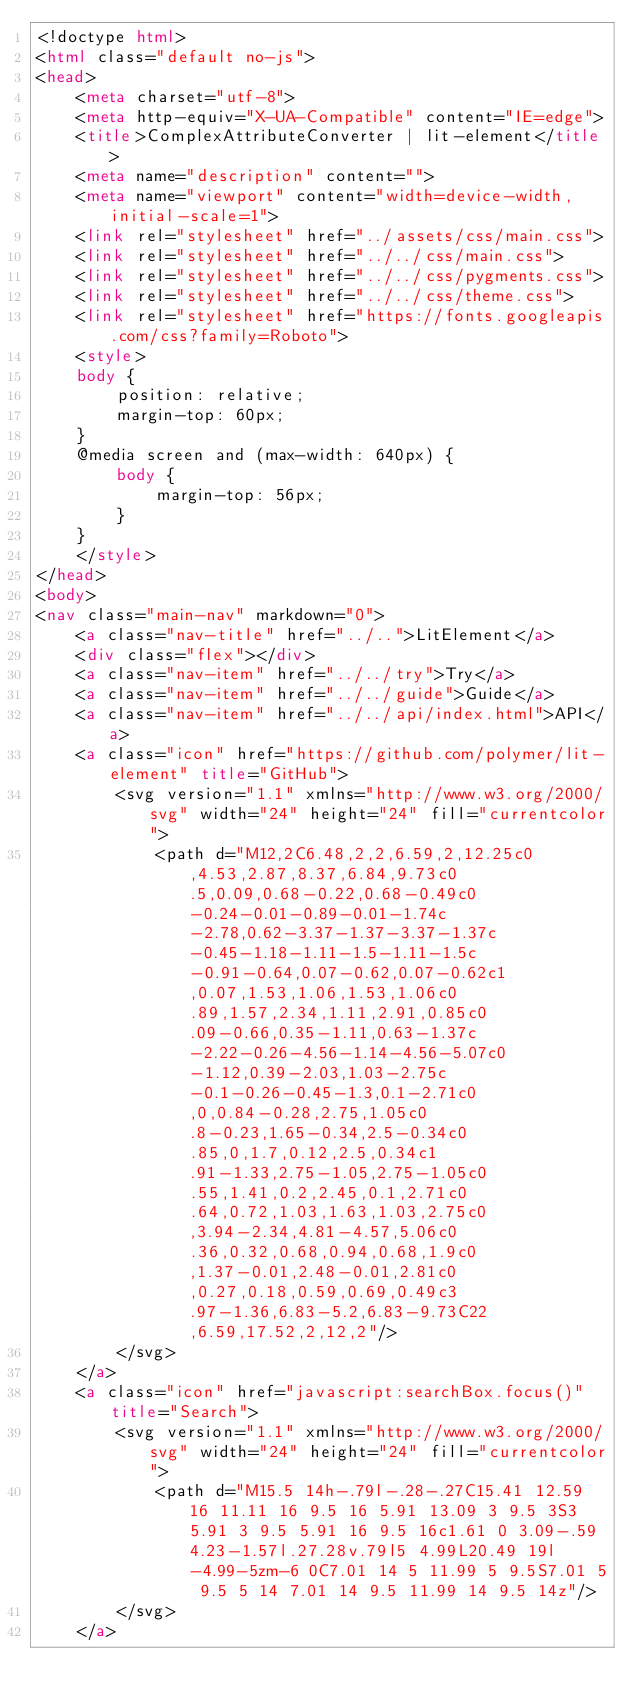Convert code to text. <code><loc_0><loc_0><loc_500><loc_500><_HTML_><!doctype html>
<html class="default no-js">
<head>
	<meta charset="utf-8">
	<meta http-equiv="X-UA-Compatible" content="IE=edge">
	<title>ComplexAttributeConverter | lit-element</title>
	<meta name="description" content="">
	<meta name="viewport" content="width=device-width, initial-scale=1">
	<link rel="stylesheet" href="../assets/css/main.css">
	<link rel="stylesheet" href="../../css/main.css">
	<link rel="stylesheet" href="../../css/pygments.css">
	<link rel="stylesheet" href="../../css/theme.css">
	<link rel="stylesheet" href="https://fonts.googleapis.com/css?family=Roboto">
	<style>
    body {
        position: relative;
        margin-top: 60px;
    }
    @media screen and (max-width: 640px) {
        body {
            margin-top: 56px;
        }
    }
    </style>
</head>
<body>
<nav class="main-nav" markdown="0">
	<a class="nav-title" href="../..">LitElement</a>
	<div class="flex"></div>
	<a class="nav-item" href="../../try">Try</a>
	<a class="nav-item" href="../../guide">Guide</a>
	<a class="nav-item" href="../../api/index.html">API</a>
	<a class="icon" href="https://github.com/polymer/lit-element" title="GitHub">
		<svg version="1.1" xmlns="http://www.w3.org/2000/svg" width="24" height="24" fill="currentcolor">
			<path d="M12,2C6.48,2,2,6.59,2,12.25c0,4.53,2.87,8.37,6.84,9.73c0.5,0.09,0.68-0.22,0.68-0.49c0-0.24-0.01-0.89-0.01-1.74c-2.78,0.62-3.37-1.37-3.37-1.37c-0.45-1.18-1.11-1.5-1.11-1.5c-0.91-0.64,0.07-0.62,0.07-0.62c1,0.07,1.53,1.06,1.53,1.06c0.89,1.57,2.34,1.11,2.91,0.85c0.09-0.66,0.35-1.11,0.63-1.37c-2.22-0.26-4.56-1.14-4.56-5.07c0-1.12,0.39-2.03,1.03-2.75c-0.1-0.26-0.45-1.3,0.1-2.71c0,0,0.84-0.28,2.75,1.05c0.8-0.23,1.65-0.34,2.5-0.34c0.85,0,1.7,0.12,2.5,0.34c1.91-1.33,2.75-1.05,2.75-1.05c0.55,1.41,0.2,2.45,0.1,2.71c0.64,0.72,1.03,1.63,1.03,2.75c0,3.94-2.34,4.81-4.57,5.06c0.36,0.32,0.68,0.94,0.68,1.9c0,1.37-0.01,2.48-0.01,2.81c0,0.27,0.18,0.59,0.69,0.49c3.97-1.36,6.83-5.2,6.83-9.73C22,6.59,17.52,2,12,2"/>
		</svg>
	</a>
	<a class="icon" href="javascript:searchBox.focus()" title="Search">
		<svg version="1.1" xmlns="http://www.w3.org/2000/svg" width="24" height="24" fill="currentcolor">
			<path d="M15.5 14h-.79l-.28-.27C15.41 12.59 16 11.11 16 9.5 16 5.91 13.09 3 9.5 3S3 5.91 3 9.5 5.91 16 9.5 16c1.61 0 3.09-.59 4.23-1.57l.27.28v.79l5 4.99L20.49 19l-4.99-5zm-6 0C7.01 14 5 11.99 5 9.5S7.01 5 9.5 5 14 7.01 14 9.5 11.99 14 9.5 14z"/>
		</svg>
	</a></code> 